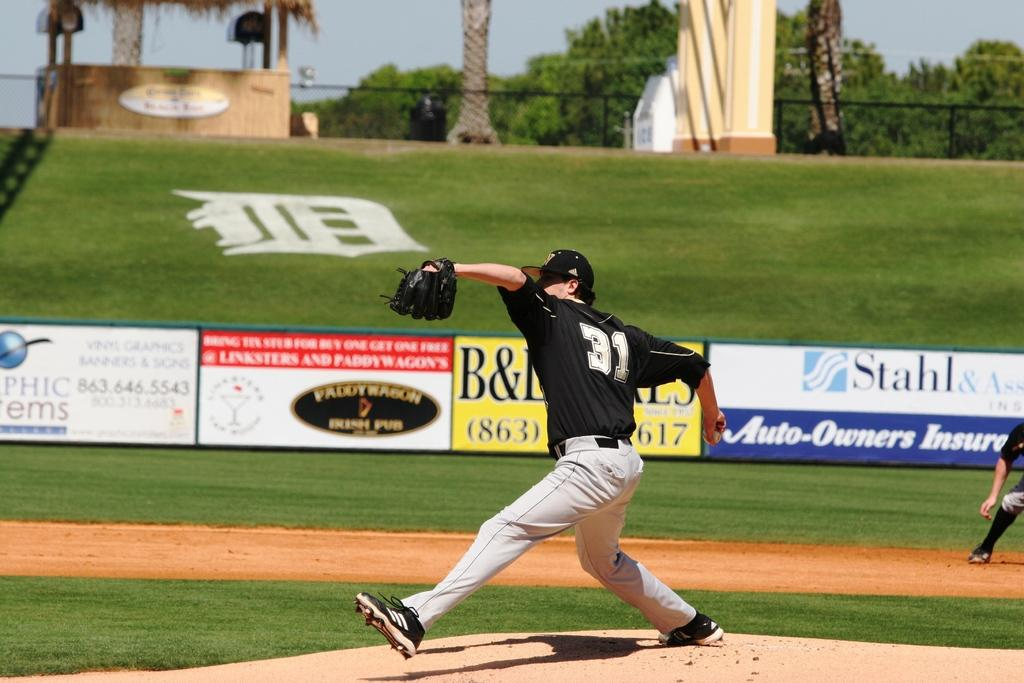<image>
Write a terse but informative summary of the picture. Player number 31 is about to pitch the ball to the other team. 